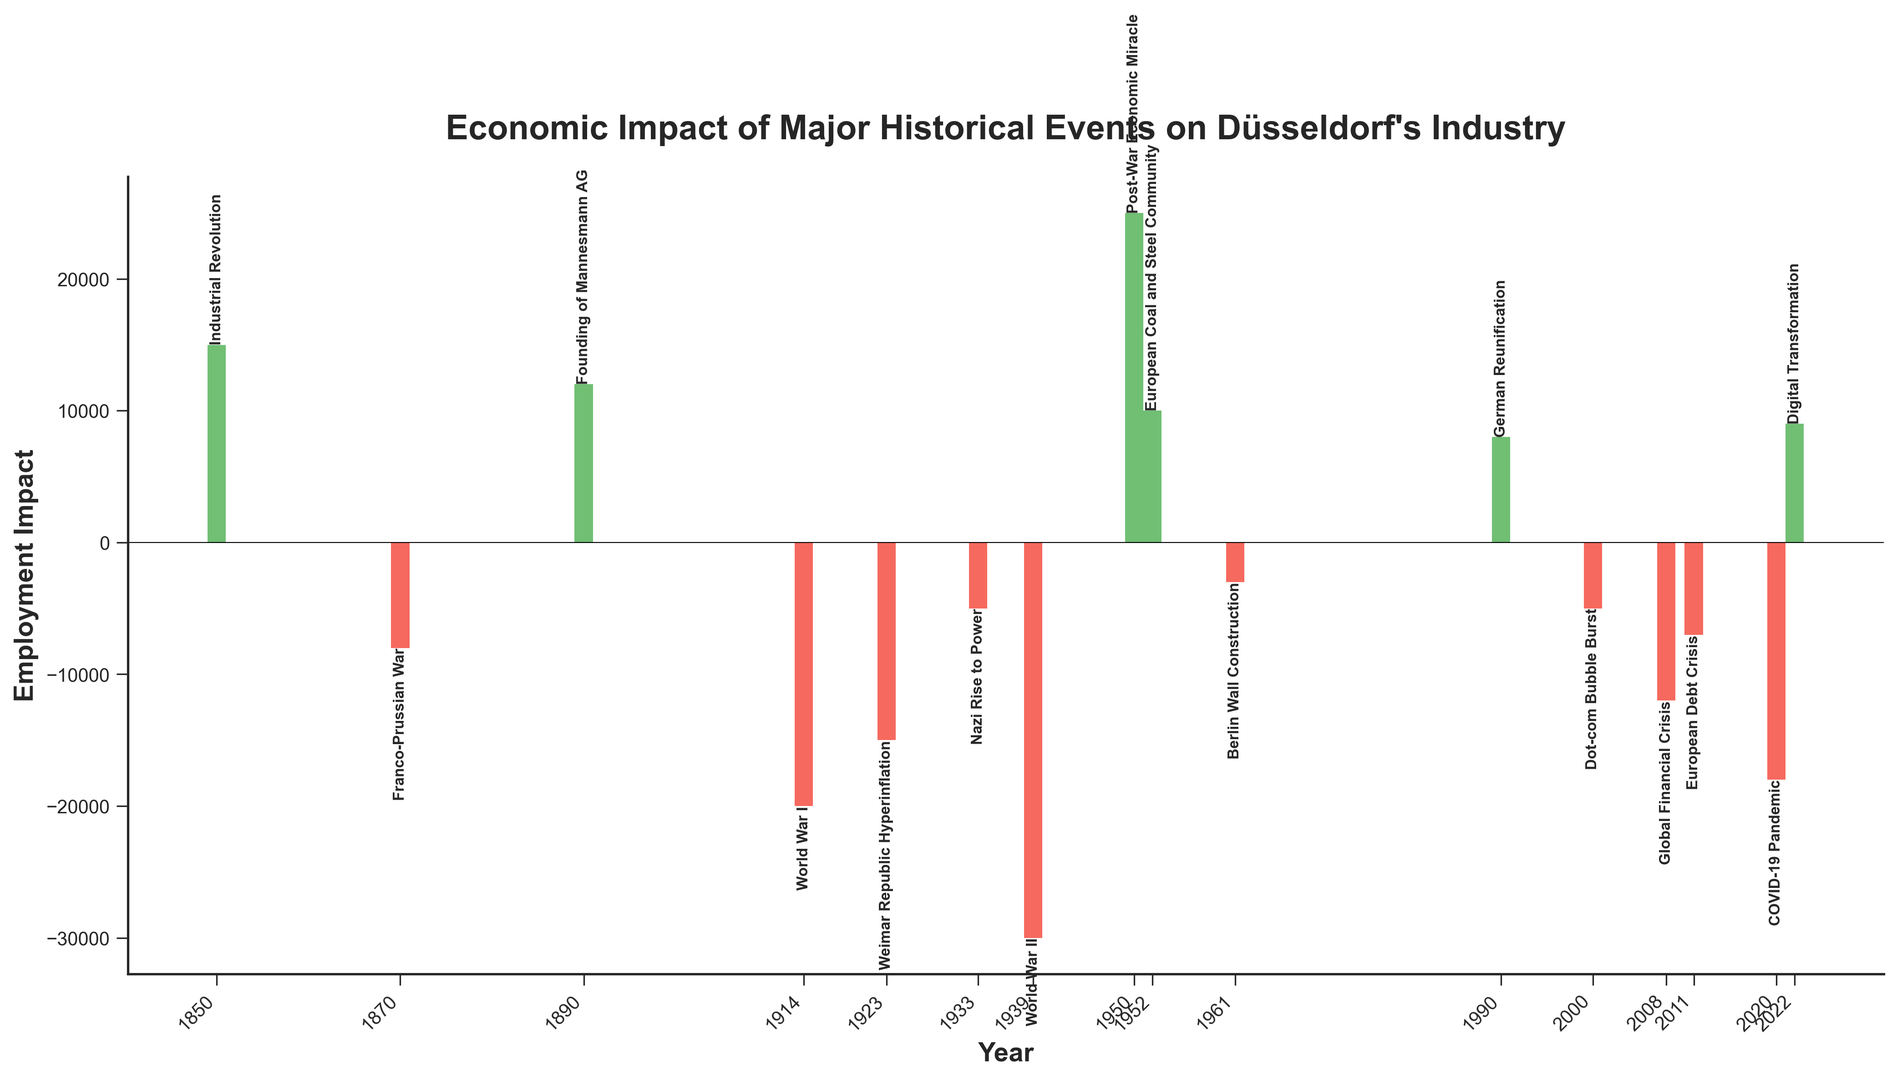What event had the most significant positive employment impact on Düsseldorf's industry? By looking at the heights of the bars above the zero line, the bar representing the Post-War Economic Miracle in 1950 has the highest value, indicating the most significant positive employment impact.
Answer: Post-War Economic Miracle Which event caused the largest decline in employment in Düsseldorf? The tallest bar below the zero line represents the largest negative employment impact. This bar corresponds to World War II in 1939.
Answer: World War II Compare the employment impact of the Franco-Prussian War and the Weimar Republic Hyperinflation. Which had a greater negative impact? To compare, look at the two bars corresponding to these events. The Franco-Prussian War (1870) has a bar with a height of -8000, whereas the Weimar Republic Hyperinflation (1923) has a bar with a height of -15000. The latter's bar is longer and hence has a greater negative impact.
Answer: Weimar Republic Hyperinflation What is the total change in employment due to World War I and World War II combined? Sum the employment impacts of World War I (-20000) and World War II (-30000). The total change is -20000 + (-30000) = -50000.
Answer: -50000 What is the difference in employment impact between the Industrial Revolution and the Founding of Mannesmann AG? Subtract the employment impact of the Industrial Revolution (15000) from that of the Founding of Mannesmann AG (12000). The difference is 15000 - 12000 = 3000.
Answer: 3000 How did the COVID-19 Pandemic affect employment compared to the Global Financial Crisis? Compare the bars for the COVID-19 Pandemic (-18000) and the Global Financial Crisis (-12000). The COVID-19 Pandemic has a larger negative impact, as its bar is longer and more negative.
Answer: COVID-19 Pandemic Identify the event with the closest positive employment impact to that of the Digital Transformation. The Digital Transformation has an employment impact of 9000. The next positive value closest to this is German Reunification in 1990, which has an impact of 8000.
Answer: German Reunification What was the employment impact trend from the Berlin Wall Construction to German Reunification? Observe the bars for the periods around these events:
- Berlin Wall Construction (1961): -3000 
- German Reunification (1990): 8000
There is a notable increase from a negative impact to a positive impact over this period.
Answer: Increase in employment impact How many events resulted in a positive employment impact on Düsseldorf's industry? Count the number of bars above the zero line. These are:
- Industrial Revolution
- Founding of Mannesmann AG
- Post-War Economic Miracle
- European Coal and Steel Community
- German Reunification
- Digital Transformation
There are 6 events in total.
Answer: 6 